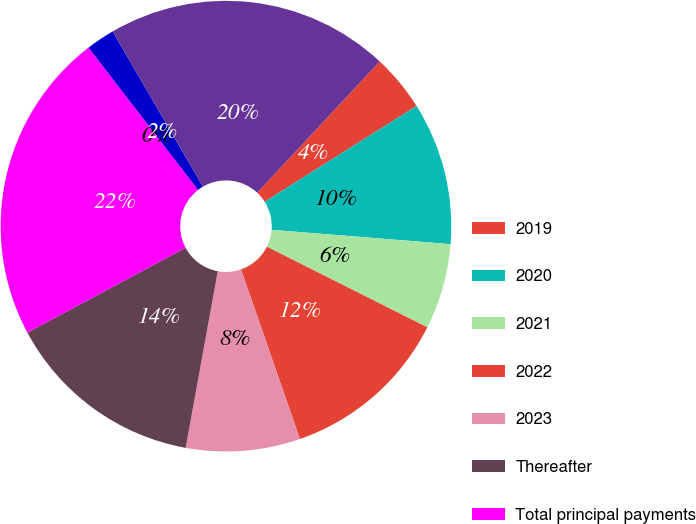Convert chart to OTSL. <chart><loc_0><loc_0><loc_500><loc_500><pie_chart><fcel>2019<fcel>2020<fcel>2021<fcel>2022<fcel>2023<fcel>Thereafter<fcel>Total principal payments<fcel>Unamortized premium on<fcel>Debt issuance costs<fcel>Total long-term debt<nl><fcel>4.09%<fcel>10.23%<fcel>6.14%<fcel>12.27%<fcel>8.18%<fcel>14.31%<fcel>22.39%<fcel>0.0%<fcel>2.05%<fcel>20.34%<nl></chart> 